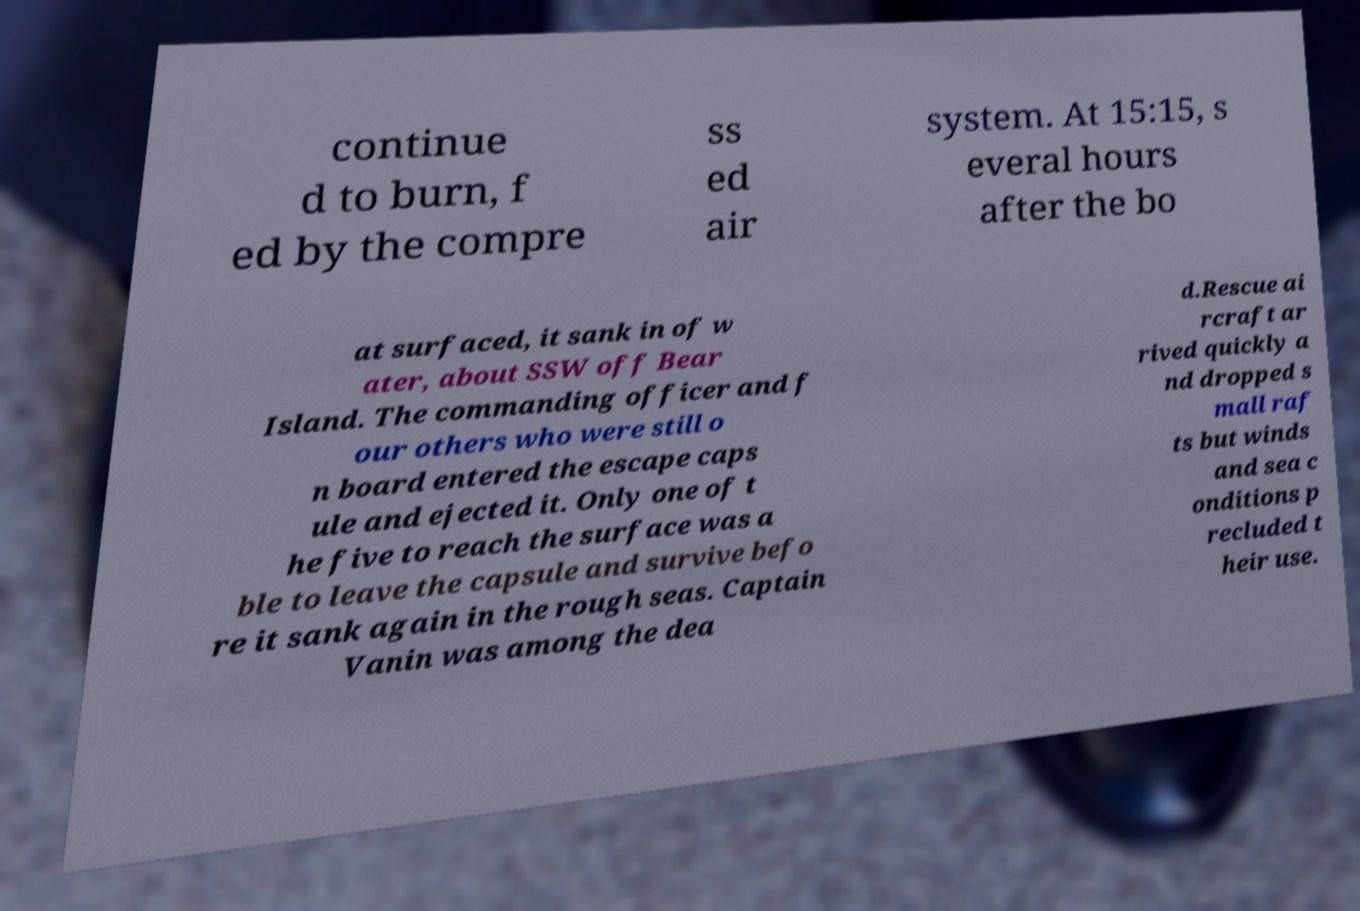I need the written content from this picture converted into text. Can you do that? continue d to burn, f ed by the compre ss ed air system. At 15:15, s everal hours after the bo at surfaced, it sank in of w ater, about SSW off Bear Island. The commanding officer and f our others who were still o n board entered the escape caps ule and ejected it. Only one of t he five to reach the surface was a ble to leave the capsule and survive befo re it sank again in the rough seas. Captain Vanin was among the dea d.Rescue ai rcraft ar rived quickly a nd dropped s mall raf ts but winds and sea c onditions p recluded t heir use. 